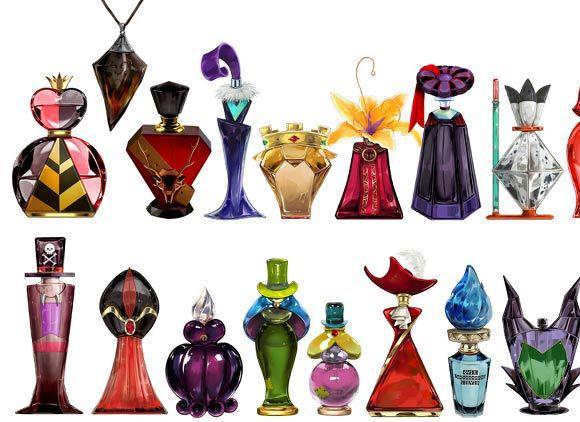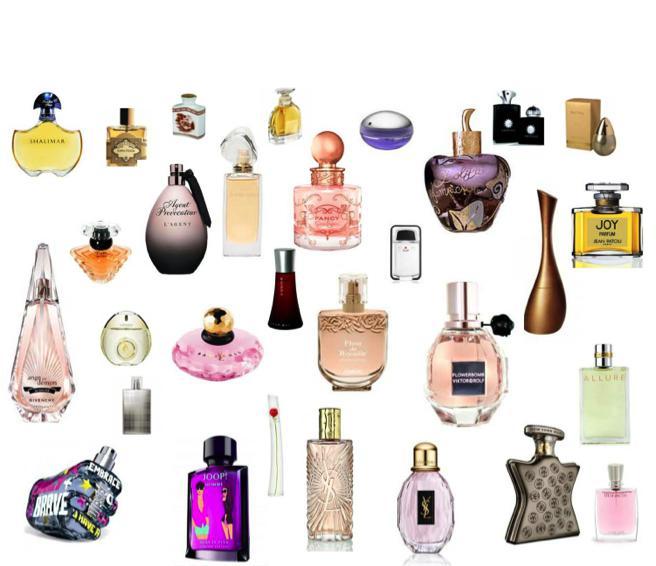The first image is the image on the left, the second image is the image on the right. For the images displayed, is the sentence "Both images show more than a dozen different perfume bottles, with a wide variety of colors, shapes, and sizes represented." factually correct? Answer yes or no. Yes. 